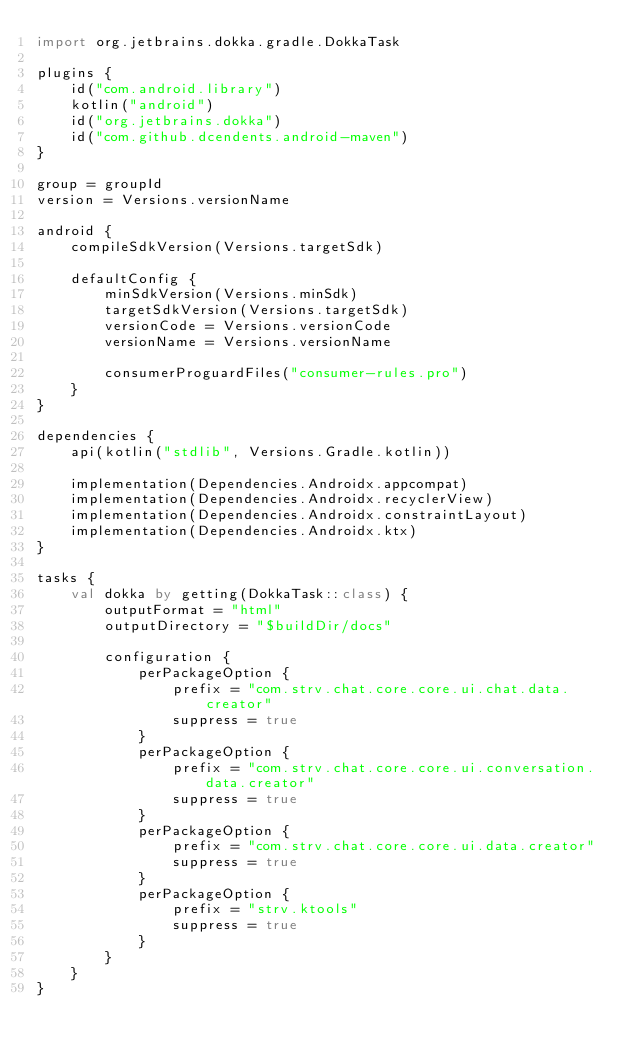<code> <loc_0><loc_0><loc_500><loc_500><_Kotlin_>import org.jetbrains.dokka.gradle.DokkaTask

plugins {
    id("com.android.library")
    kotlin("android")
    id("org.jetbrains.dokka")
    id("com.github.dcendents.android-maven")
}

group = groupId
version = Versions.versionName

android {
    compileSdkVersion(Versions.targetSdk)

    defaultConfig {
        minSdkVersion(Versions.minSdk)
        targetSdkVersion(Versions.targetSdk)
        versionCode = Versions.versionCode
        versionName = Versions.versionName

        consumerProguardFiles("consumer-rules.pro")
    }
}

dependencies {
    api(kotlin("stdlib", Versions.Gradle.kotlin))

    implementation(Dependencies.Androidx.appcompat)
    implementation(Dependencies.Androidx.recyclerView)
    implementation(Dependencies.Androidx.constraintLayout)
    implementation(Dependencies.Androidx.ktx)
}

tasks {
    val dokka by getting(DokkaTask::class) {
        outputFormat = "html"
        outputDirectory = "$buildDir/docs"

        configuration {
            perPackageOption {
                prefix = "com.strv.chat.core.core.ui.chat.data.creator"
                suppress = true
            }
            perPackageOption {
                prefix = "com.strv.chat.core.core.ui.conversation.data.creator"
                suppress = true
            }
            perPackageOption {
                prefix = "com.strv.chat.core.core.ui.data.creator"
                suppress = true
            }
            perPackageOption {
                prefix = "strv.ktools"
                suppress = true
            }
        }
    }
}</code> 